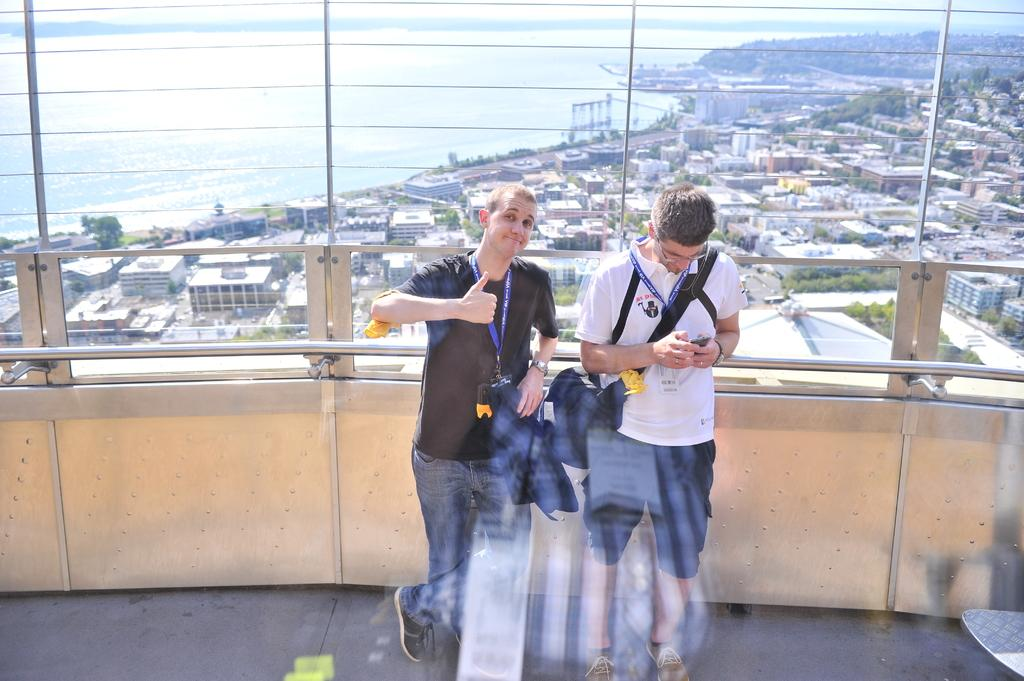How many men are present in the image? There are two men in the image. What are the men holding or carrying? The men are carrying bags. Where are the men standing? The men are standing on the floor. What can be seen in the background of the image? There is a fence, buildings, water, trees, and the sky visible in the background of the image. How many dimes can be seen on the ground in the image? There are no dimes visible on the ground in the image. Are there any flies buzzing around the men in the image? There is no mention of flies in the image, so it cannot be determined if any are present. 